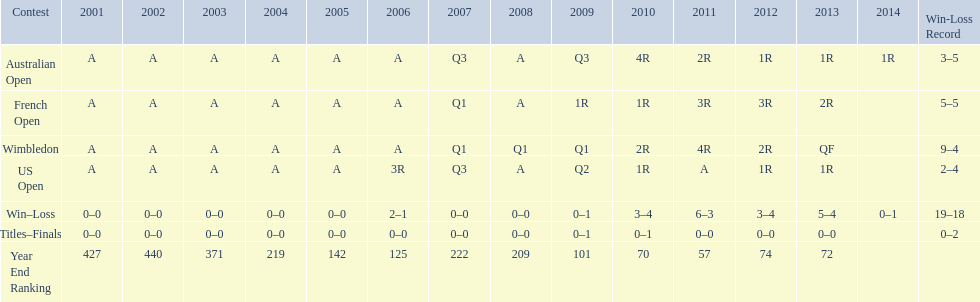In which years were there only 1 loss? 2006, 2009, 2014. Could you parse the entire table as a dict? {'header': ['Contest', '2001', '2002', '2003', '2004', '2005', '2006', '2007', '2008', '2009', '2010', '2011', '2012', '2013', '2014', 'Win-Loss Record'], 'rows': [['Australian Open', 'A', 'A', 'A', 'A', 'A', 'A', 'Q3', 'A', 'Q3', '4R', '2R', '1R', '1R', '1R', '3–5'], ['French Open', 'A', 'A', 'A', 'A', 'A', 'A', 'Q1', 'A', '1R', '1R', '3R', '3R', '2R', '', '5–5'], ['Wimbledon', 'A', 'A', 'A', 'A', 'A', 'A', 'Q1', 'Q1', 'Q1', '2R', '4R', '2R', 'QF', '', '9–4'], ['US Open', 'A', 'A', 'A', 'A', 'A', '3R', 'Q3', 'A', 'Q2', '1R', 'A', '1R', '1R', '', '2–4'], ['Win–Loss', '0–0', '0–0', '0–0', '0–0', '0–0', '2–1', '0–0', '0–0', '0–1', '3–4', '6–3', '3–4', '5–4', '0–1', '19–18'], ['Titles–Finals', '0–0', '0–0', '0–0', '0–0', '0–0', '0–0', '0–0', '0–0', '0–1', '0–1', '0–0', '0–0', '0–0', '', '0–2'], ['Year End Ranking', '427', '440', '371', '219', '142', '125', '222', '209', '101', '70', '57', '74', '72', '', '']]} 